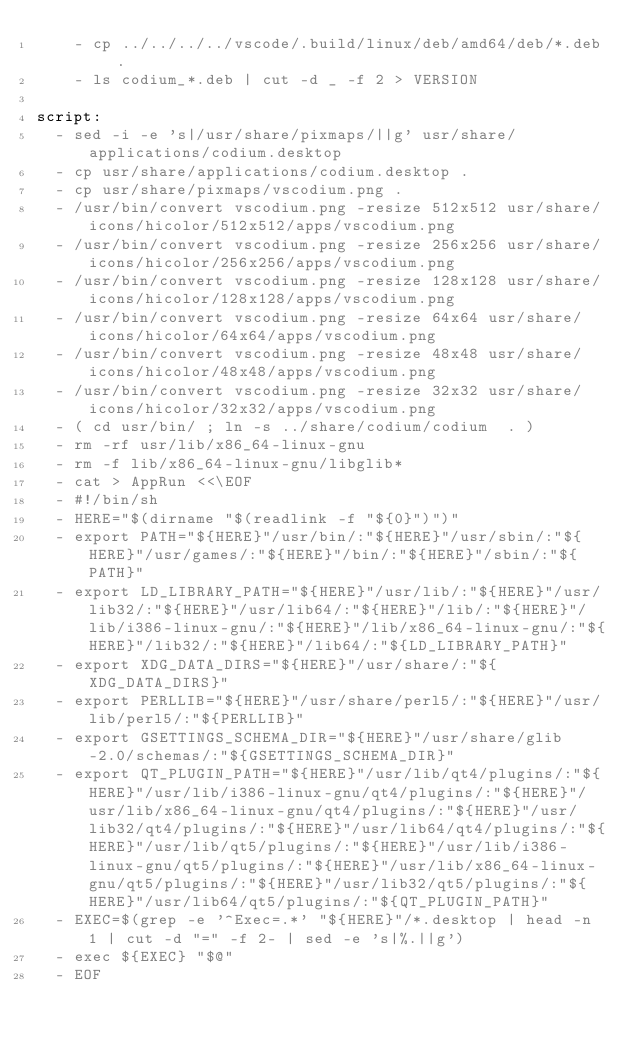Convert code to text. <code><loc_0><loc_0><loc_500><loc_500><_YAML_>    - cp ../../../../vscode/.build/linux/deb/amd64/deb/*.deb .
    - ls codium_*.deb | cut -d _ -f 2 > VERSION

script:
  - sed -i -e 's|/usr/share/pixmaps/||g' usr/share/applications/codium.desktop
  - cp usr/share/applications/codium.desktop .
  - cp usr/share/pixmaps/vscodium.png .
  - /usr/bin/convert vscodium.png -resize 512x512 usr/share/icons/hicolor/512x512/apps/vscodium.png
  - /usr/bin/convert vscodium.png -resize 256x256 usr/share/icons/hicolor/256x256/apps/vscodium.png
  - /usr/bin/convert vscodium.png -resize 128x128 usr/share/icons/hicolor/128x128/apps/vscodium.png
  - /usr/bin/convert vscodium.png -resize 64x64 usr/share/icons/hicolor/64x64/apps/vscodium.png
  - /usr/bin/convert vscodium.png -resize 48x48 usr/share/icons/hicolor/48x48/apps/vscodium.png
  - /usr/bin/convert vscodium.png -resize 32x32 usr/share/icons/hicolor/32x32/apps/vscodium.png
  - ( cd usr/bin/ ; ln -s ../share/codium/codium  . )
  - rm -rf usr/lib/x86_64-linux-gnu
  - rm -f lib/x86_64-linux-gnu/libglib*
  - cat > AppRun <<\EOF
  - #!/bin/sh
  - HERE="$(dirname "$(readlink -f "${0}")")"
  - export PATH="${HERE}"/usr/bin/:"${HERE}"/usr/sbin/:"${HERE}"/usr/games/:"${HERE}"/bin/:"${HERE}"/sbin/:"${PATH}"
  - export LD_LIBRARY_PATH="${HERE}"/usr/lib/:"${HERE}"/usr/lib32/:"${HERE}"/usr/lib64/:"${HERE}"/lib/:"${HERE}"/lib/i386-linux-gnu/:"${HERE}"/lib/x86_64-linux-gnu/:"${HERE}"/lib32/:"${HERE}"/lib64/:"${LD_LIBRARY_PATH}"
  - export XDG_DATA_DIRS="${HERE}"/usr/share/:"${XDG_DATA_DIRS}"
  - export PERLLIB="${HERE}"/usr/share/perl5/:"${HERE}"/usr/lib/perl5/:"${PERLLIB}"
  - export GSETTINGS_SCHEMA_DIR="${HERE}"/usr/share/glib-2.0/schemas/:"${GSETTINGS_SCHEMA_DIR}"
  - export QT_PLUGIN_PATH="${HERE}"/usr/lib/qt4/plugins/:"${HERE}"/usr/lib/i386-linux-gnu/qt4/plugins/:"${HERE}"/usr/lib/x86_64-linux-gnu/qt4/plugins/:"${HERE}"/usr/lib32/qt4/plugins/:"${HERE}"/usr/lib64/qt4/plugins/:"${HERE}"/usr/lib/qt5/plugins/:"${HERE}"/usr/lib/i386-linux-gnu/qt5/plugins/:"${HERE}"/usr/lib/x86_64-linux-gnu/qt5/plugins/:"${HERE}"/usr/lib32/qt5/plugins/:"${HERE}"/usr/lib64/qt5/plugins/:"${QT_PLUGIN_PATH}"
  - EXEC=$(grep -e '^Exec=.*' "${HERE}"/*.desktop | head -n 1 | cut -d "=" -f 2- | sed -e 's|%.||g')
  - exec ${EXEC} "$@"
  - EOF
</code> 